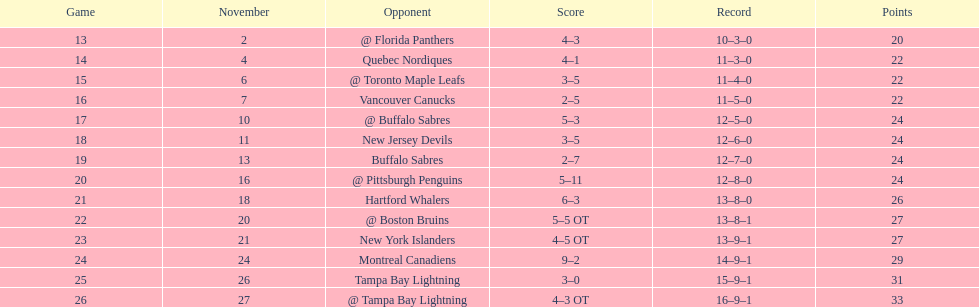Who recorded the highest number of assists for the 1993-1994 flyers? Mark Recchi. 